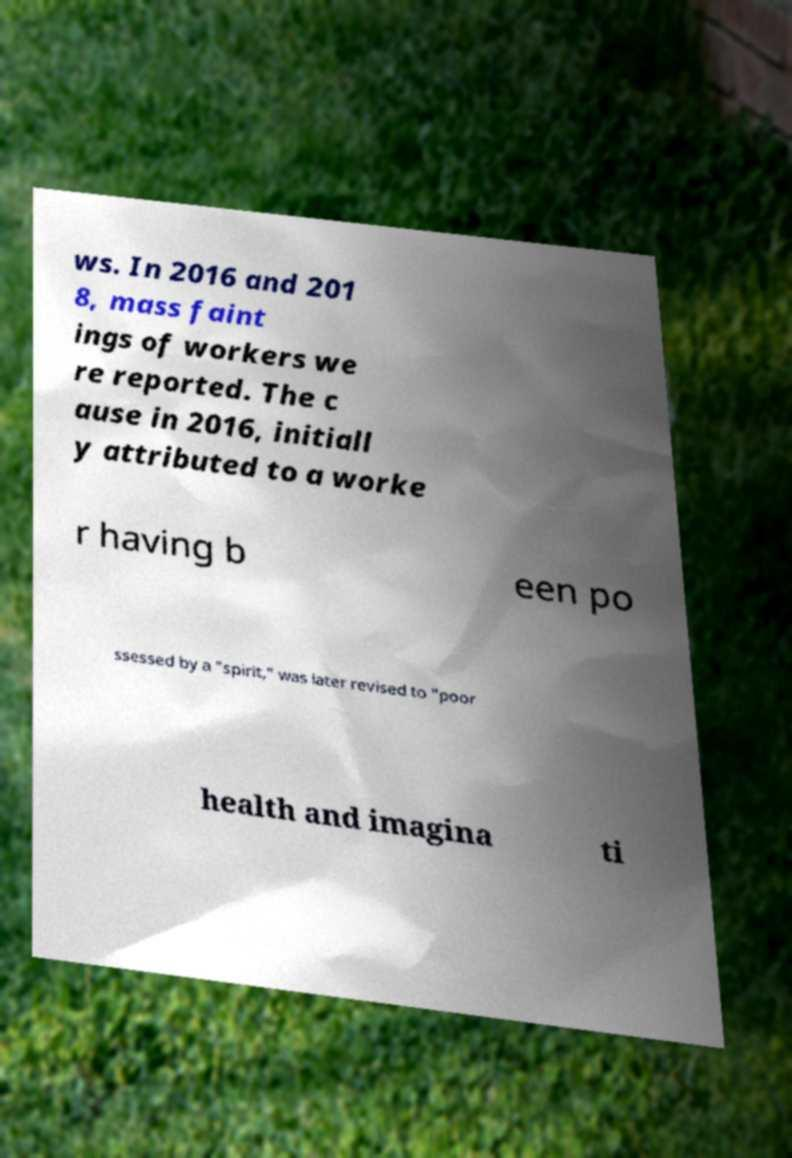Could you assist in decoding the text presented in this image and type it out clearly? ws. In 2016 and 201 8, mass faint ings of workers we re reported. The c ause in 2016, initiall y attributed to a worke r having b een po ssessed by a "spirit," was later revised to "poor health and imagina ti 